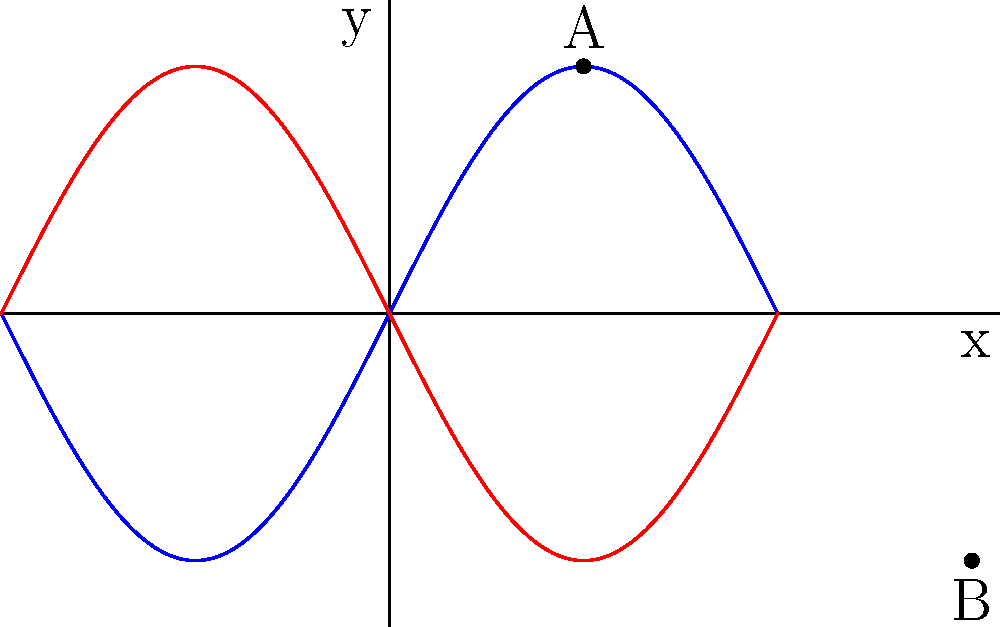In the analysis of symmetry in ancient pottery designs, a particular pattern is represented by the blue curve in the 2D coordinate plane above. If point A represents the highest point of a decorative motif, what transformation would map point A to point B to create a symmetrical design often found in ancient ceramics? To determine the transformation that maps point A to point B, we need to analyze their positions and the nature of the curves:

1. Point A is located at $(\frac{\pi}{2}, 2)$ on the blue curve.
2. Point B is located at $(\frac{3\pi}{2}, -2)$ on the red curve.
3. The blue curve is described by the function $f(x) = 2\sin(x)$.
4. The red curve is described by the function $g(x) = -2\sin(x)$.

Analyzing these facts, we can deduce:

1. The x-coordinate of B is $\pi$ units to the right of A's x-coordinate.
2. The y-coordinate of B is the negative of A's y-coordinate.
3. The red curve is a reflection of the blue curve across the x-axis.

These observations suggest that the transformation from A to B involves two steps:
1. A horizontal translation of $\pi$ units to the right.
2. A reflection across the x-axis.

In mathematical terms, this can be expressed as:
1. Translation: $(x, y) \rightarrow (x + \pi, y)$
2. Reflection: $(x, y) \rightarrow (x, -y)$

Combining these, we get: $(x, y) \rightarrow (x + \pi, -y)$

This transformation is known as a glide reflection, which is a common symmetry found in ancient pottery designs. It combines a translation with a reflection, creating a repeating pattern that maintains balance and symmetry around the circumference of a ceramic vessel.
Answer: Glide reflection 